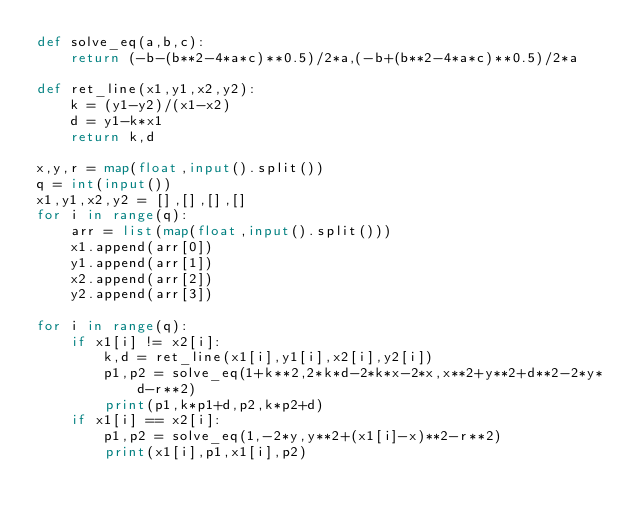Convert code to text. <code><loc_0><loc_0><loc_500><loc_500><_Python_>def solve_eq(a,b,c):
    return (-b-(b**2-4*a*c)**0.5)/2*a,(-b+(b**2-4*a*c)**0.5)/2*a

def ret_line(x1,y1,x2,y2):
    k = (y1-y2)/(x1-x2)
    d = y1-k*x1
    return k,d
    
x,y,r = map(float,input().split())
q = int(input())
x1,y1,x2,y2 = [],[],[],[]
for i in range(q):
    arr = list(map(float,input().split()))
    x1.append(arr[0])
    y1.append(arr[1])
    x2.append(arr[2])
    y2.append(arr[3])

for i in range(q):
    if x1[i] != x2[i]:
        k,d = ret_line(x1[i],y1[i],x2[i],y2[i])
        p1,p2 = solve_eq(1+k**2,2*k*d-2*k*x-2*x,x**2+y**2+d**2-2*y*d-r**2)
        print(p1,k*p1+d,p2,k*p2+d)
    if x1[i] == x2[i]:
        p1,p2 = solve_eq(1,-2*y,y**2+(x1[i]-x)**2-r**2)
        print(x1[i],p1,x1[i],p2)</code> 